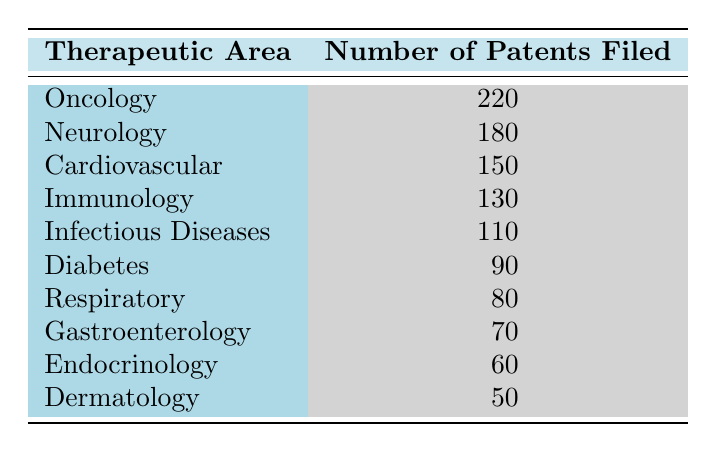What therapeutic area has the highest number of patents filed? The table shows the number of patents filed for various therapeutic areas. By looking at the data, "Oncology" has the highest number with 220 patents filed.
Answer: Oncology How many patents were filed in the Diabetes therapeutic area? The table specifies that the number of patents filed for Diabetes is clearly listed as 90.
Answer: 90 What is the total number of patents filed across all therapeutic areas? We sum the patents filed: 220 (Oncology) + 180 (Neurology) + 150 (Cardiovascular) + 130 (Immunology) + 110 (Infectious Diseases) + 90 (Diabetes) + 80 (Respiratory) + 70 (Gastroenterology) + 60 (Endocrinology) + 50 (Dermatology) = 1,210.
Answer: 1210 Is there a therapeutic area with fewer than 70 patents filed? Looking at the table, the therapeutic areas with filed patents are Gastroenterology (70), Endocrinology (60), and Dermatology (50). Hence, there are definitely areas with fewer than 70 patents filed.
Answer: Yes What is the difference in the number of patents filed between Immunology and Infectious Diseases? The number of patents filed in Immunology is 130 and in Infectious Diseases is 110. The difference is 130 - 110 = 20.
Answer: 20 What is the average number of patents filed in the top three therapeutic areas? The top three areas are Oncology (220), Neurology (180), and Cardiovascular (150). Summing these gives 220 + 180 + 150 = 550. Then, dividing by the number of top areas (3), we calculate 550 / 3 = approximately 183.33.
Answer: Approximately 183.33 Which therapeutic area has the least number of patents filed, and how many are there? The table indicates that "Dermatology" has the least number of patents filed, which is 50.
Answer: Dermatology, 50 Is the number of patents filed for Neurology greater than that for Immunology? The figure shows that Neurology has 180 patents while Immunology has 130. Since 180 is greater than 130, we conclude that Neurology does indeed have more patents.
Answer: Yes 